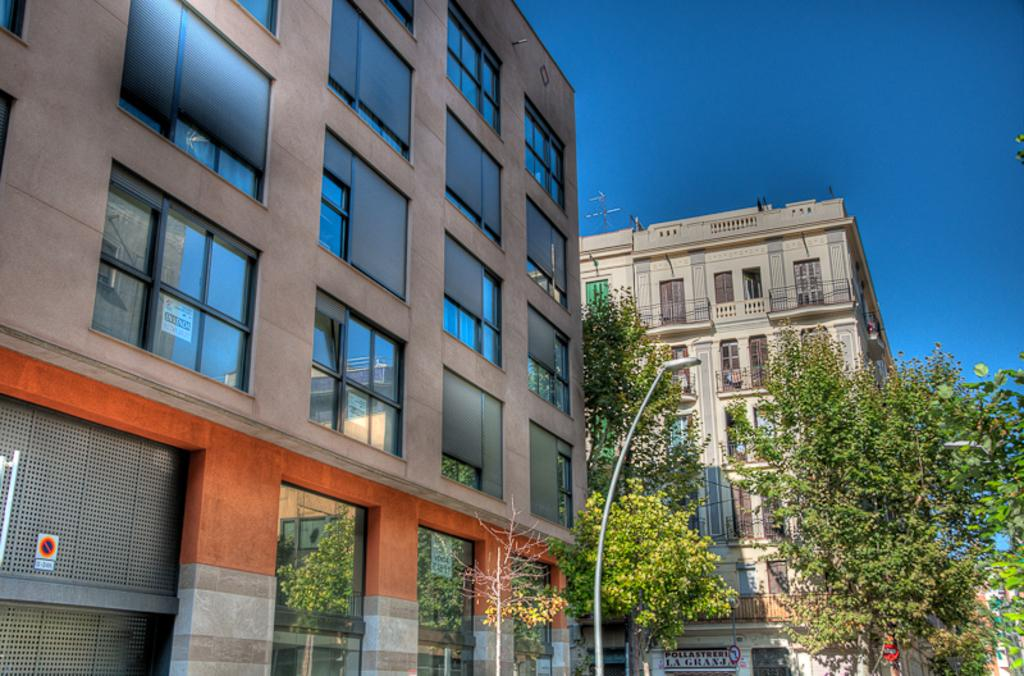What type of structures are visible in the image? There are buildings with windows in the image. What other natural elements can be seen in the image? There are trees in the image. What object is present that might be used for support or signage? There is a pole in the image. What can be seen in the distance in the image? The sky is visible in the background of the image. What type of wound can be seen on the governor in the image? There is no governor or wound present in the image. What material is the brass used for in the image? There is no brass present in the image. 